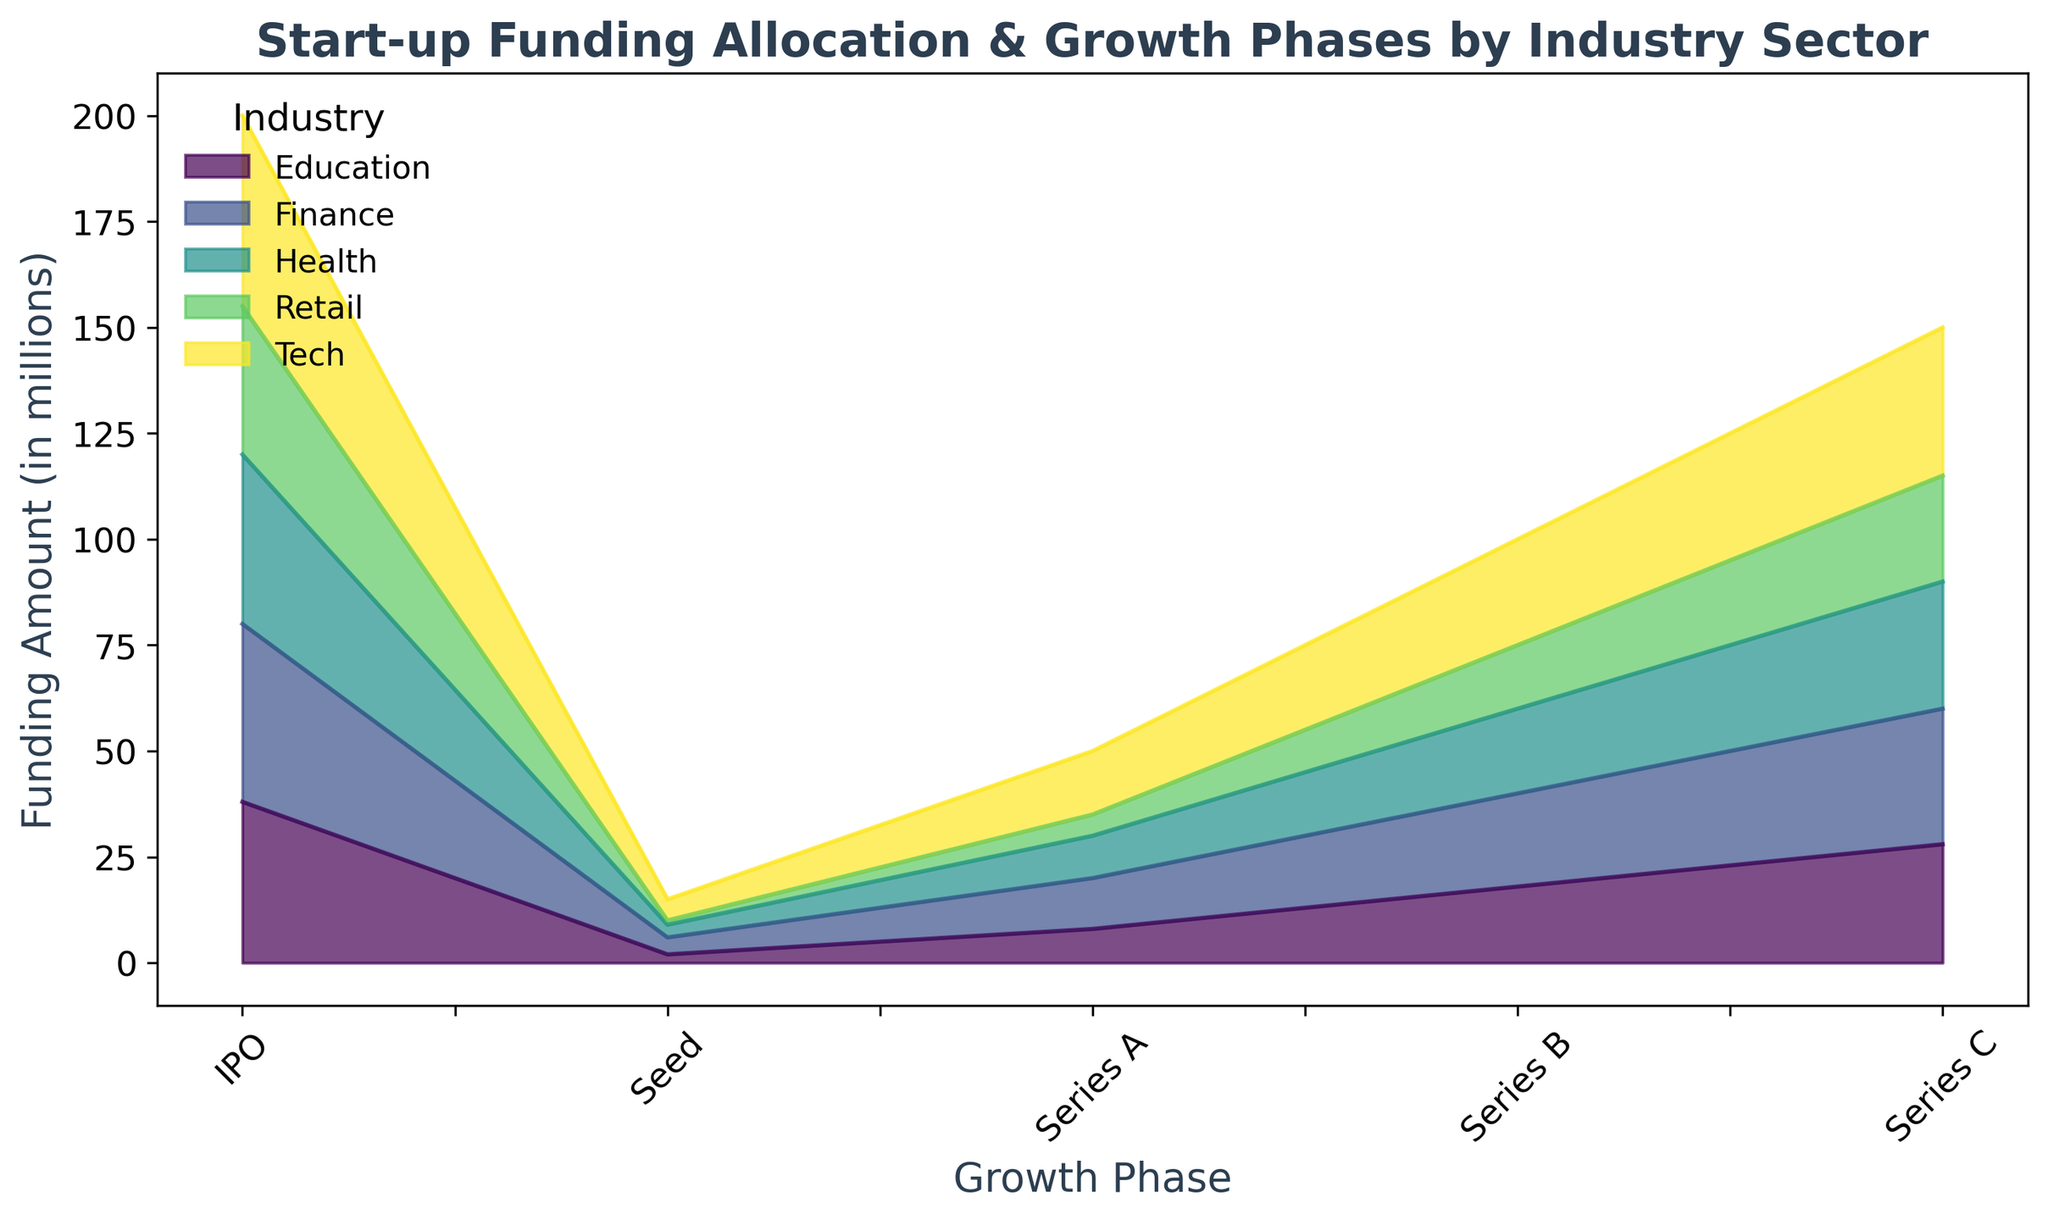Which industry receives the most funding at the IPO phase? Look at the topmost area in the graph at the IPO phase (rightmost side). The industry with the highest allocated area is Tech.
Answer: Tech Which industry experiences the lowest funding at the Seed phase? Look at the bottom areas in the graph at the Seed phase (leftmost side). The industry with the smallest allocated area is Retail.
Answer: Retail What is the total funding amount in the Series B phase? Sum the funding amounts for all industries at the Series B phase. The values are 25 (Tech) + 20 (Health) + 22 (Finance) + 18 (Education) + 15 (Retail), totaling 100.
Answer: 100 How does the funding amount for Tech change from Seed to Series A? Calculate the difference in funding amounts for Tech between Seed and Series A phases. Seed phase value is 5 and Series A phase value is 15, so 15 - 5 = 10.
Answer: 10 Compare funding amounts for Health and Finance at the Series C phase. Which is higher and by how much? Look at the funding allocated for Health and Finance at Series C phase. Health has 30, Finance has 32. The difference is 32 - 30 = 2, with Finance being higher.
Answer: Finance, 2 What is the visual difference between Tech and Retail funding trends? Observe the areas for Tech and Retail across all phases. Tech's area consistently increases and stays above Retail at all phases, while Retail starts very small and remains the lowest throughout.
Answer: Tech consistently higher Calculate the average funding amount across all phases for Education. Sum the funding amounts for Education in all phases and divide by the number of phases. (2 + 8 + 18 + 28 + 38) / 5 = 94 / 5 = 18.8.
Answer: 18.8 Which industry shows the steepest increase in funding between Series A and Series C? Compare the funding increases from Series A to Series C across industries. Tech increases from 15 to 35, Health from 10 to 30, Finance from 12 to 32, Education from 8 to 28, Retail from 5 to 25. The steepest increase is in Tech.
Answer: Tech 